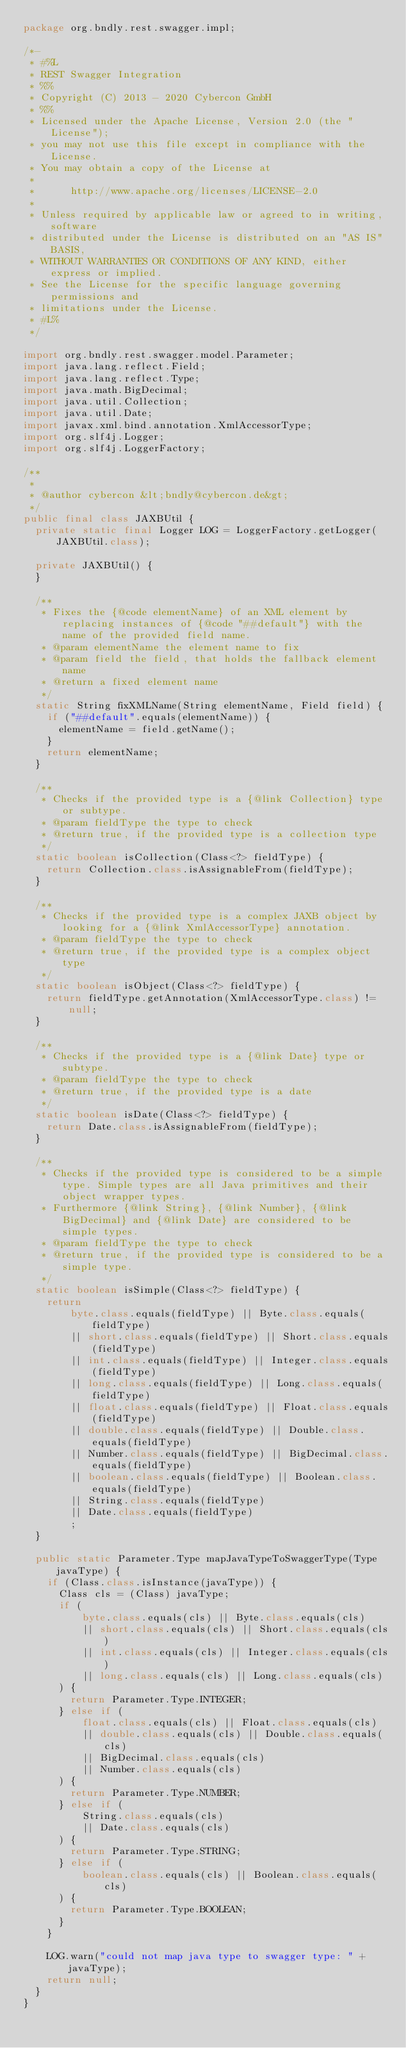Convert code to text. <code><loc_0><loc_0><loc_500><loc_500><_Java_>package org.bndly.rest.swagger.impl;

/*-
 * #%L
 * REST Swagger Integration
 * %%
 * Copyright (C) 2013 - 2020 Cybercon GmbH
 * %%
 * Licensed under the Apache License, Version 2.0 (the "License");
 * you may not use this file except in compliance with the License.
 * You may obtain a copy of the License at
 * 
 *      http://www.apache.org/licenses/LICENSE-2.0
 * 
 * Unless required by applicable law or agreed to in writing, software
 * distributed under the License is distributed on an "AS IS" BASIS,
 * WITHOUT WARRANTIES OR CONDITIONS OF ANY KIND, either express or implied.
 * See the License for the specific language governing permissions and
 * limitations under the License.
 * #L%
 */

import org.bndly.rest.swagger.model.Parameter;
import java.lang.reflect.Field;
import java.lang.reflect.Type;
import java.math.BigDecimal;
import java.util.Collection;
import java.util.Date;
import javax.xml.bind.annotation.XmlAccessorType;
import org.slf4j.Logger;
import org.slf4j.LoggerFactory;

/**
 *
 * @author cybercon &lt;bndly@cybercon.de&gt;
 */
public final class JAXBUtil {
	private static final Logger LOG = LoggerFactory.getLogger(JAXBUtil.class);

	private JAXBUtil() {
	}
	
	/**
	 * Fixes the {@code elementName} of an XML element by replacing instances of {@code "##default"} with the name of the provided field name.
	 * @param elementName the element name to fix
	 * @param field the field, that holds the fallback element name
	 * @return a fixed element name
	 */
	static String fixXMLName(String elementName, Field field) {
		if ("##default".equals(elementName)) {
			elementName = field.getName();
		}
		return elementName;
	}
	
	/**
	 * Checks if the provided type is a {@link Collection} type or subtype.
	 * @param fieldType the type to check
	 * @return true, if the provided type is a collection type
	 */
	static boolean isCollection(Class<?> fieldType) {
		return Collection.class.isAssignableFrom(fieldType);
	}

	/**
	 * Checks if the provided type is a complex JAXB object by looking for a {@link XmlAccessorType} annotation.
	 * @param fieldType the type to check
	 * @return true, if the provided type is a complex object type
	 */
	static boolean isObject(Class<?> fieldType) {
		return fieldType.getAnnotation(XmlAccessorType.class) != null;
	}
	
	/**
	 * Checks if the provided type is a {@link Date} type or subtype.
	 * @param fieldType the type to check
	 * @return true, if the provided type is a date
	 */
	static boolean isDate(Class<?> fieldType) {
		return Date.class.isAssignableFrom(fieldType);
	}
	
	/**
	 * Checks if the provided type is considered to be a simple type. Simple types are all Java primitives and their object wrapper types. 
	 * Furthermore {@link String}, {@link Number}, {@link BigDecimal} and {@link Date} are considered to be simple types.
	 * @param fieldType the type to check
	 * @return true, if the provided type is considered to be a simple type.
	 */
	static boolean isSimple(Class<?> fieldType) {
		return 
				byte.class.equals(fieldType) || Byte.class.equals(fieldType)
				|| short.class.equals(fieldType) || Short.class.equals(fieldType)
				|| int.class.equals(fieldType) || Integer.class.equals(fieldType)
				|| long.class.equals(fieldType) || Long.class.equals(fieldType)
				|| float.class.equals(fieldType) || Float.class.equals(fieldType)
				|| double.class.equals(fieldType) || Double.class.equals(fieldType)
				|| Number.class.equals(fieldType) || BigDecimal.class.equals(fieldType)
				|| boolean.class.equals(fieldType) || Boolean.class.equals(fieldType)
				|| String.class.equals(fieldType)
				|| Date.class.equals(fieldType)
				;
	}
	
	public static Parameter.Type mapJavaTypeToSwaggerType(Type javaType) {
		if (Class.class.isInstance(javaType)) {
			Class cls = (Class) javaType;
			if (
					byte.class.equals(cls) || Byte.class.equals(cls)
					|| short.class.equals(cls) || Short.class.equals(cls)
					|| int.class.equals(cls) || Integer.class.equals(cls)
					|| long.class.equals(cls) || Long.class.equals(cls)
			) {
				return Parameter.Type.INTEGER;
			} else if (
					float.class.equals(cls) || Float.class.equals(cls)
					|| double.class.equals(cls) || Double.class.equals(cls)
					|| BigDecimal.class.equals(cls)
					|| Number.class.equals(cls)
			) {
				return Parameter.Type.NUMBER;
			} else if (
					String.class.equals(cls)
					|| Date.class.equals(cls)
			) {
				return Parameter.Type.STRING;
			} else if (
					boolean.class.equals(cls) || Boolean.class.equals(cls)
			) {
				return Parameter.Type.BOOLEAN;
			}
		}

		LOG.warn("could not map java type to swagger type: " + javaType);
		return null;
	}
}
</code> 